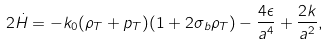<formula> <loc_0><loc_0><loc_500><loc_500>2 \dot { H } = - k _ { 0 } ( \rho _ { T } + p _ { T } ) ( 1 + 2 \sigma _ { b } \rho _ { T } ) - \frac { 4 \epsilon } { a ^ { 4 } } + \frac { 2 k } { a ^ { 2 } } ,</formula> 